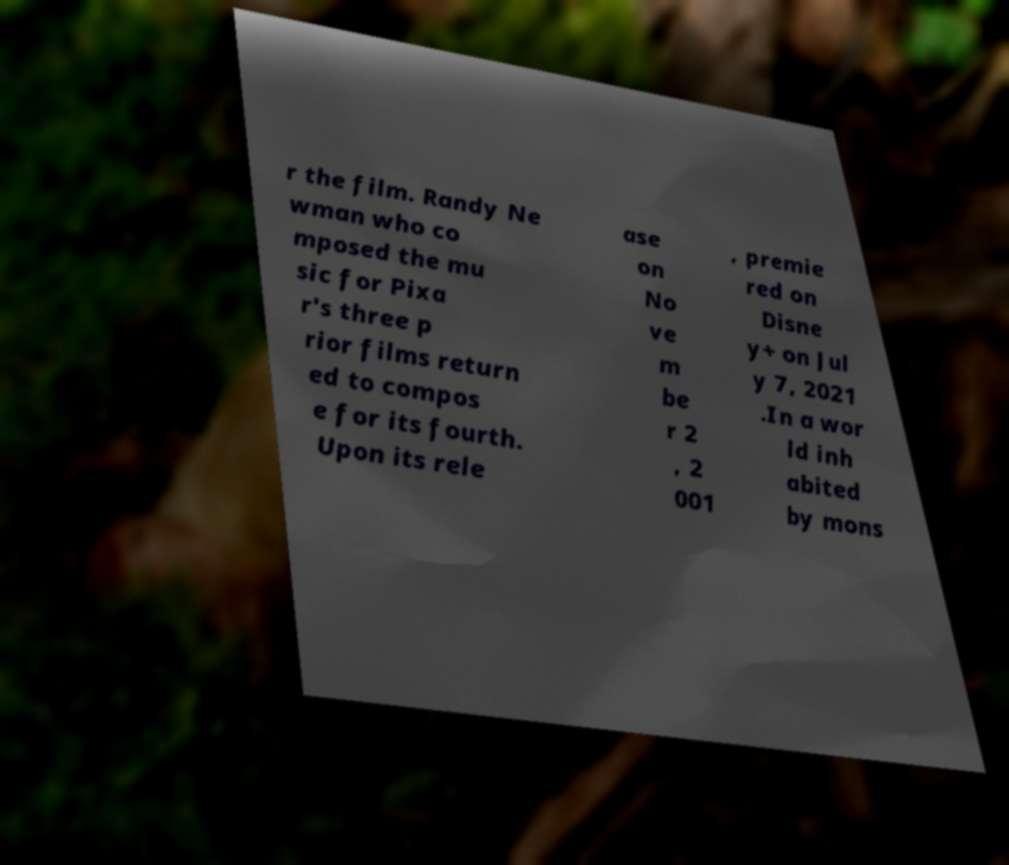For documentation purposes, I need the text within this image transcribed. Could you provide that? r the film. Randy Ne wman who co mposed the mu sic for Pixa r's three p rior films return ed to compos e for its fourth. Upon its rele ase on No ve m be r 2 , 2 001 , premie red on Disne y+ on Jul y 7, 2021 .In a wor ld inh abited by mons 